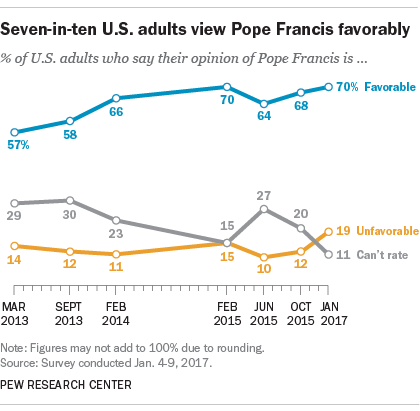Specify some key components in this picture. The yellow line represents unfavorable conditions. In order to analyze the three sets of opinion data, we must calculate the median of each set and then sum them up. 